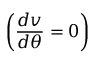Convert formula to latex. <formula><loc_0><loc_0><loc_500><loc_500>\left ( \frac { d v } { d \theta } = 0 \right )</formula> 